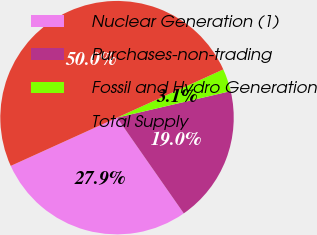Convert chart to OTSL. <chart><loc_0><loc_0><loc_500><loc_500><pie_chart><fcel>Nuclear Generation (1)<fcel>Purchases-non-trading<fcel>Fossil and Hydro Generation<fcel>Total Supply<nl><fcel>27.91%<fcel>18.96%<fcel>3.13%<fcel>50.0%<nl></chart> 